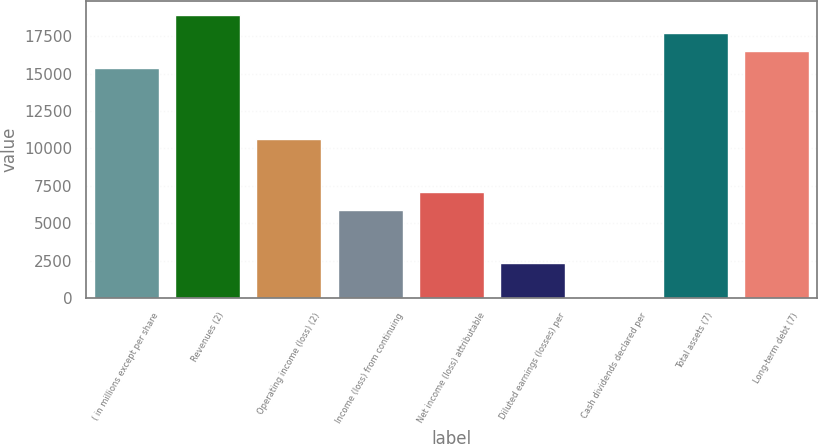Convert chart to OTSL. <chart><loc_0><loc_0><loc_500><loc_500><bar_chart><fcel>( in millions except per share<fcel>Revenues (2)<fcel>Operating income (loss) (2)<fcel>Income (loss) from continuing<fcel>Net income (loss) attributable<fcel>Diluted earnings (losses) per<fcel>Cash dividends declared per<fcel>Total assets (7)<fcel>Long-term debt (7)<nl><fcel>15358<fcel>18902.1<fcel>10632.6<fcel>5907.24<fcel>7088.59<fcel>2363.19<fcel>0.49<fcel>17720.7<fcel>16539.4<nl></chart> 